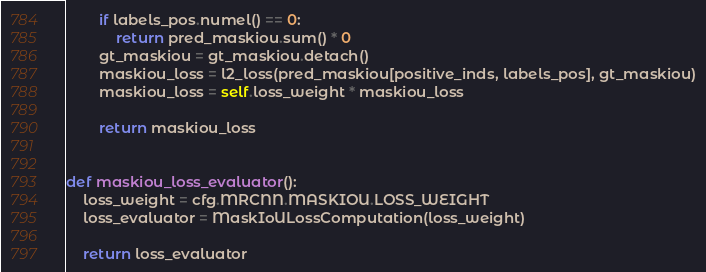Convert code to text. <code><loc_0><loc_0><loc_500><loc_500><_Python_>        if labels_pos.numel() == 0:
            return pred_maskiou.sum() * 0
        gt_maskiou = gt_maskiou.detach()
        maskiou_loss = l2_loss(pred_maskiou[positive_inds, labels_pos], gt_maskiou)
        maskiou_loss = self.loss_weight * maskiou_loss

        return maskiou_loss


def maskiou_loss_evaluator():
    loss_weight = cfg.MRCNN.MASKIOU.LOSS_WEIGHT
    loss_evaluator = MaskIoULossComputation(loss_weight)

    return loss_evaluator
</code> 